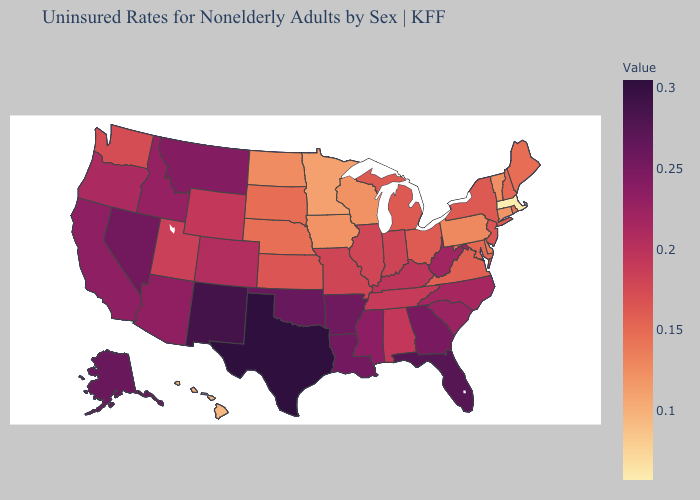Does New York have the highest value in the Northeast?
Concise answer only. No. Does California have the highest value in the West?
Keep it brief. No. Among the states that border Michigan , does Wisconsin have the highest value?
Short answer required. No. Which states have the highest value in the USA?
Be succinct. Texas. Among the states that border New York , does New Jersey have the lowest value?
Concise answer only. No. Among the states that border California , which have the lowest value?
Keep it brief. Oregon. Among the states that border Florida , which have the lowest value?
Give a very brief answer. Alabama. Is the legend a continuous bar?
Short answer required. Yes. Does North Dakota have a lower value than Massachusetts?
Write a very short answer. No. 